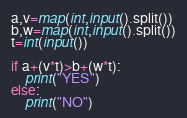Convert code to text. <code><loc_0><loc_0><loc_500><loc_500><_Python_>a,v=map(int,input().split())
b,w=map(int,input().split())
t=int(input())

if a+(v*t)>b+(w*t):
    print("YES")
else:
    print("NO")</code> 